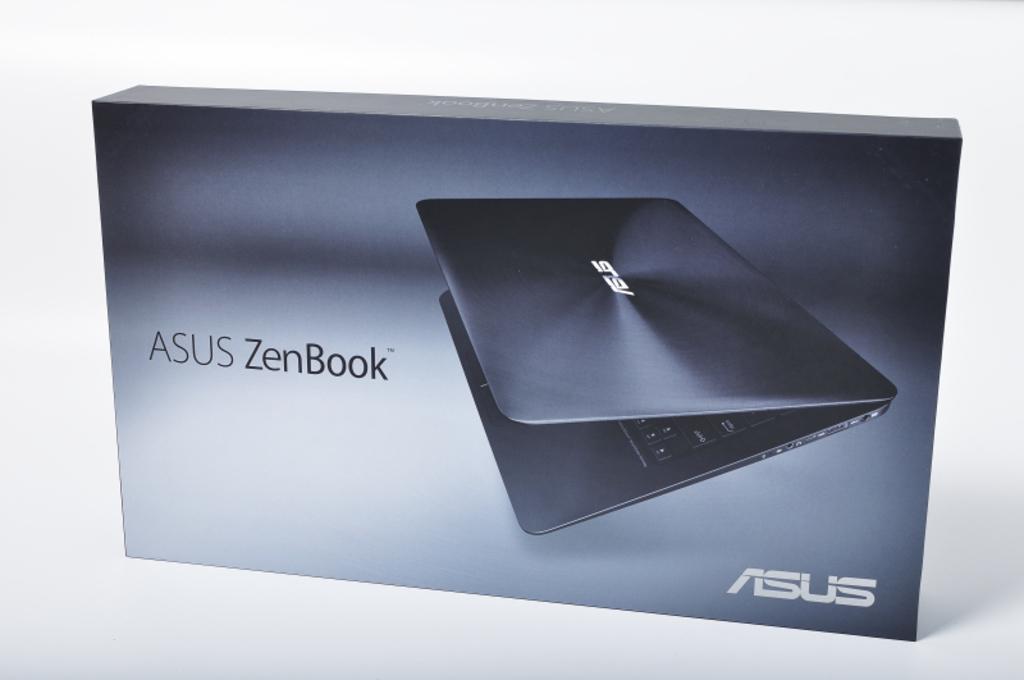What is the brand of notebook?
Provide a succinct answer. Asus. What model is the notebook?
Provide a short and direct response. Asus. 